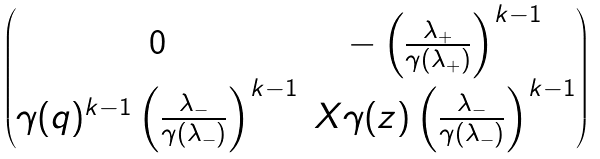<formula> <loc_0><loc_0><loc_500><loc_500>\begin{pmatrix} 0 & - \left ( \frac { \lambda _ { + } } { \gamma ( \lambda _ { + } ) } \right ) ^ { k - 1 } \\ \gamma ( q ) ^ { k - 1 } \left ( \frac { \lambda _ { - } } { \gamma ( \lambda _ { - } ) } \right ) ^ { k - 1 } & X \gamma ( z ) \left ( \frac { \lambda _ { - } } { \gamma ( \lambda _ { - } ) } \right ) ^ { k - 1 } \end{pmatrix}</formula> 